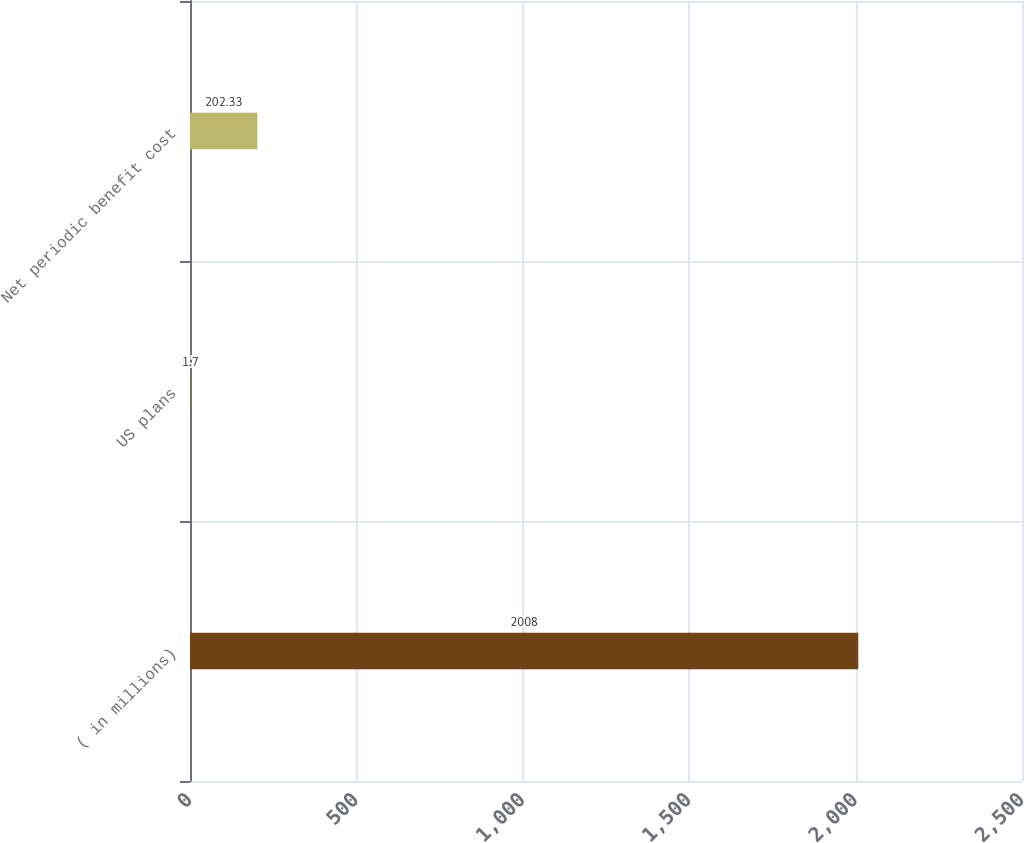Convert chart. <chart><loc_0><loc_0><loc_500><loc_500><bar_chart><fcel>( in millions)<fcel>US plans<fcel>Net periodic benefit cost<nl><fcel>2008<fcel>1.7<fcel>202.33<nl></chart> 